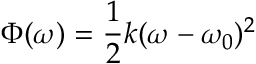<formula> <loc_0><loc_0><loc_500><loc_500>\Phi ( \omega ) = \frac { 1 } { 2 } k ( \omega - \omega _ { 0 } ) ^ { 2 }</formula> 